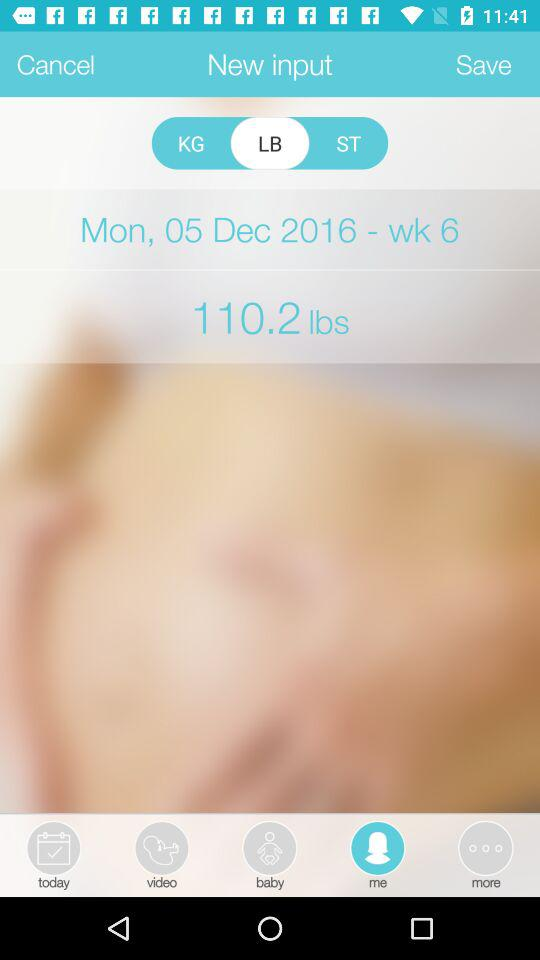What is the shown date? The shown date is Monday, December 5, 2016. 